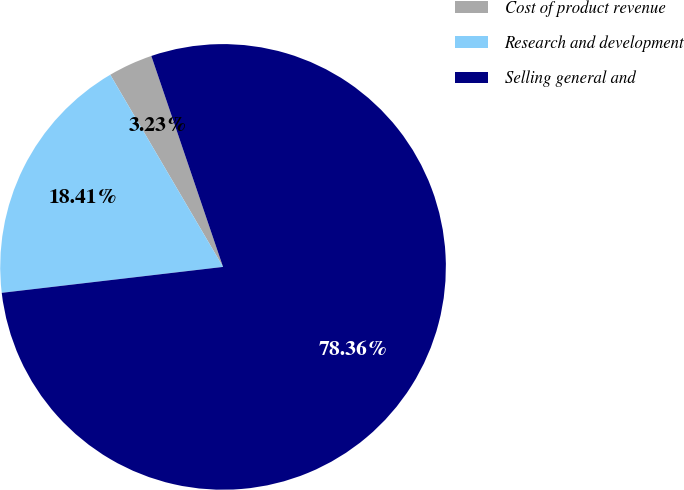Convert chart to OTSL. <chart><loc_0><loc_0><loc_500><loc_500><pie_chart><fcel>Cost of product revenue<fcel>Research and development<fcel>Selling general and<nl><fcel>3.23%<fcel>18.41%<fcel>78.36%<nl></chart> 